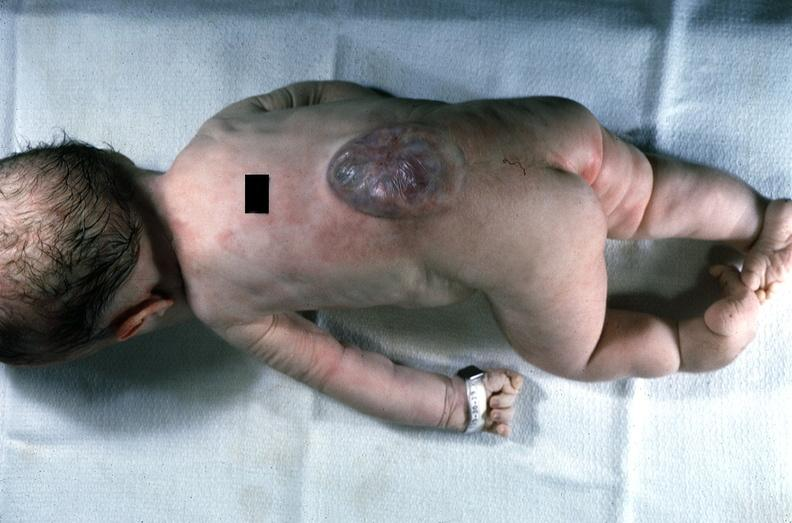does this image show neural tube defect?
Answer the question using a single word or phrase. Yes 